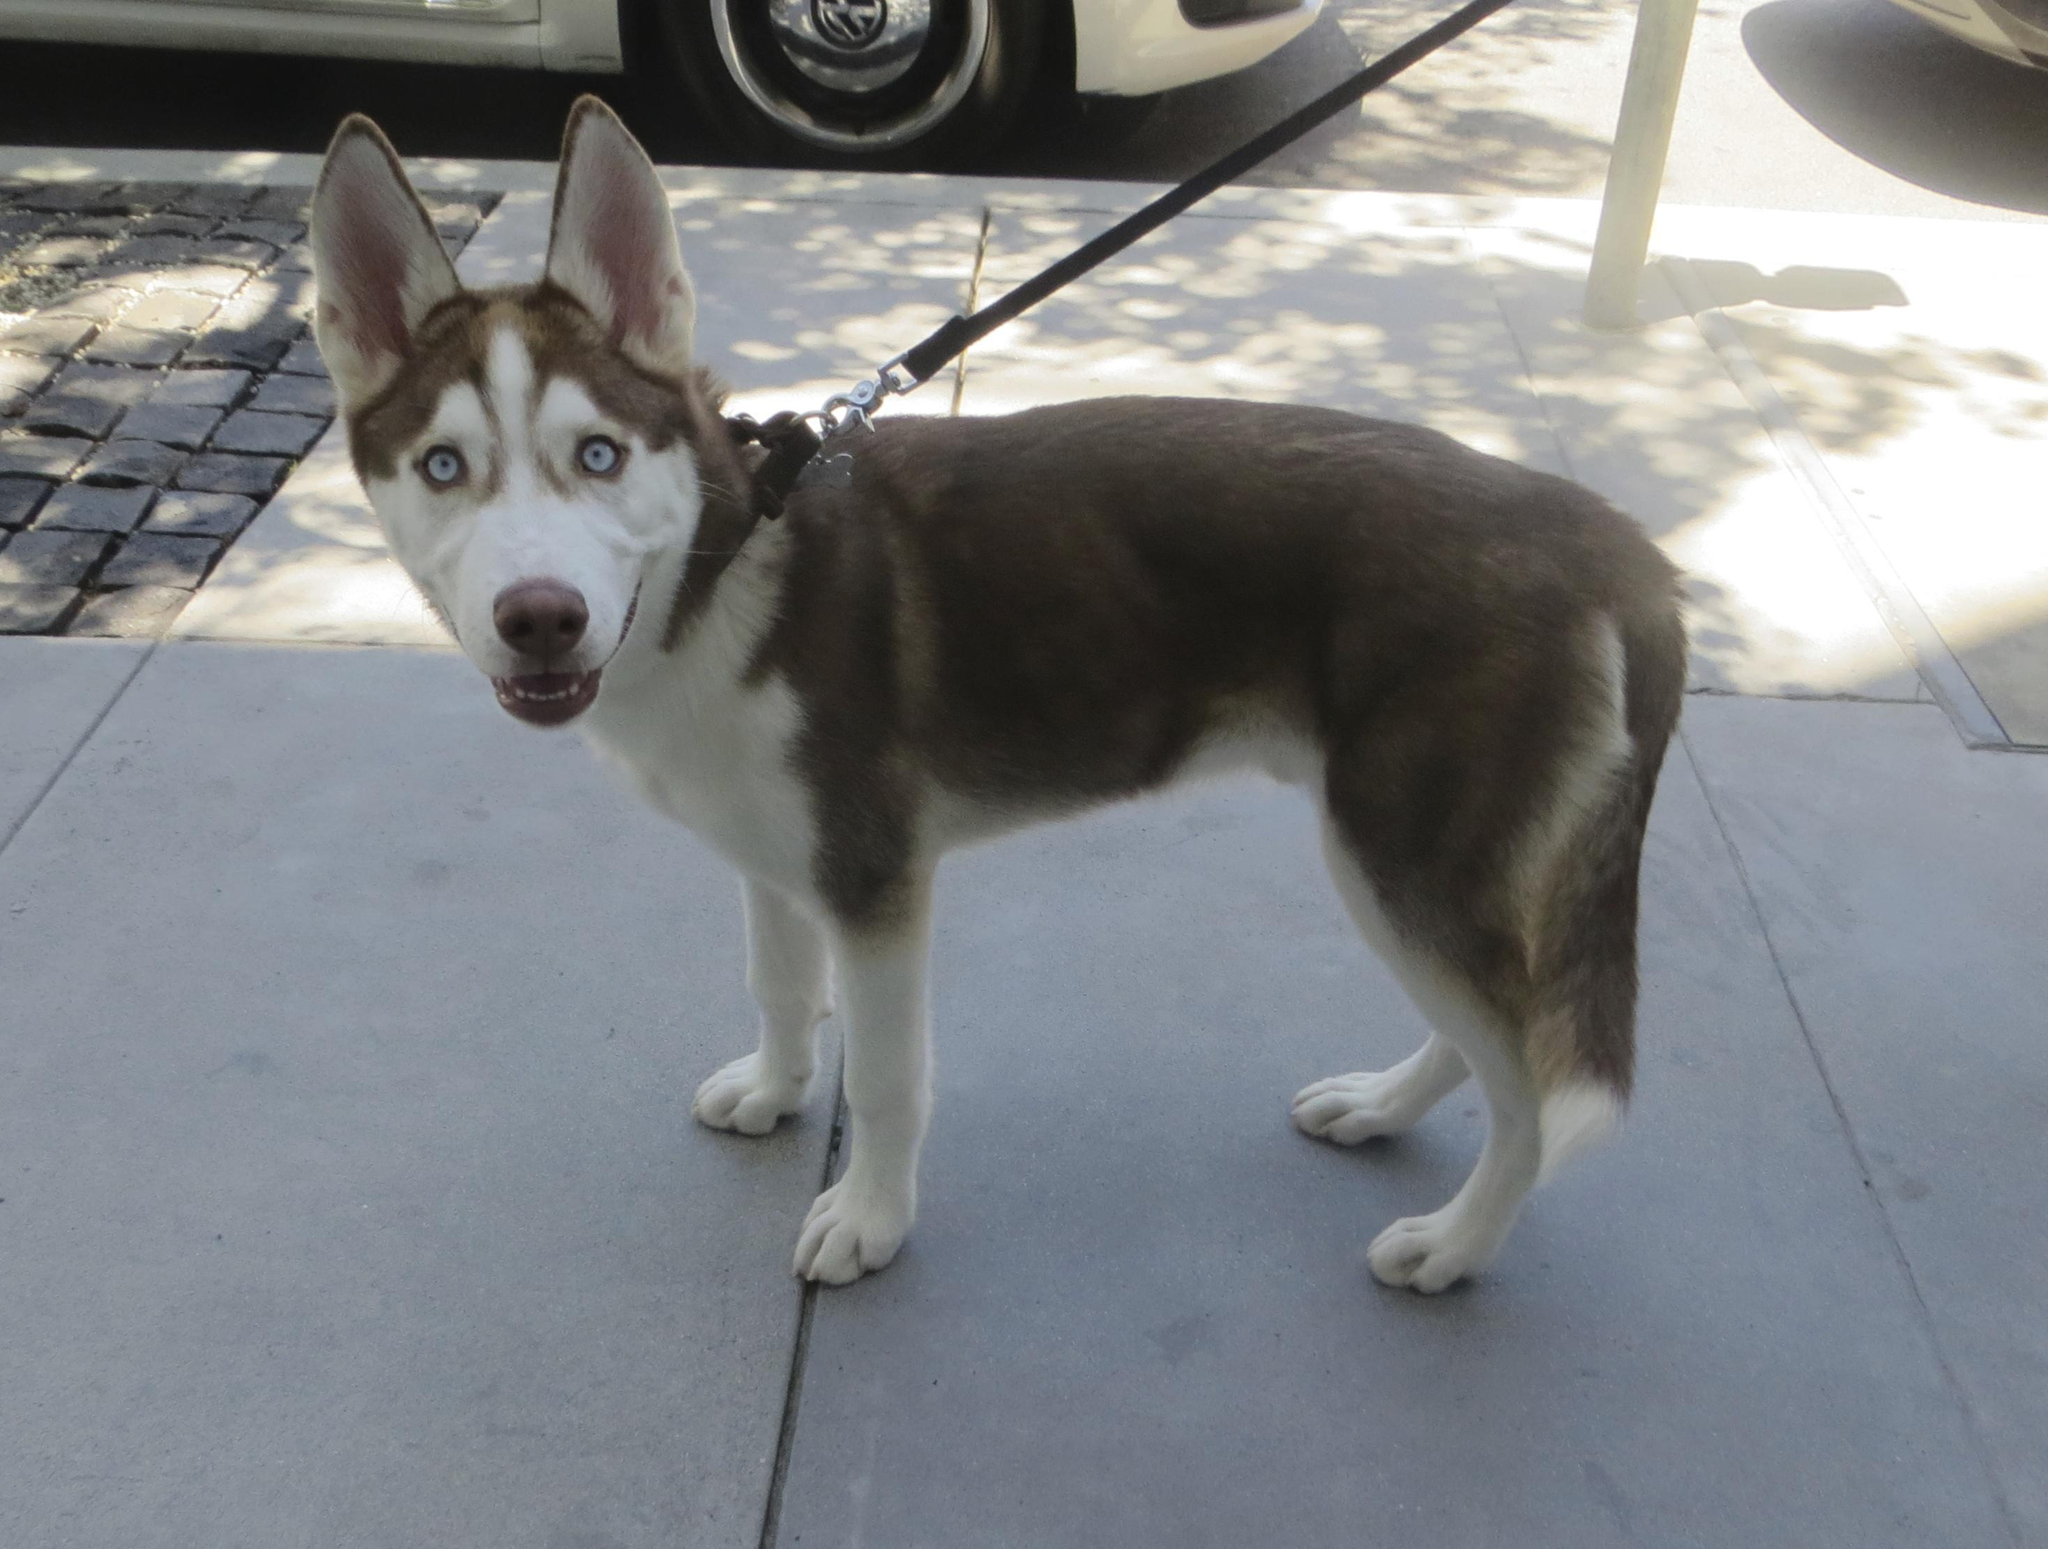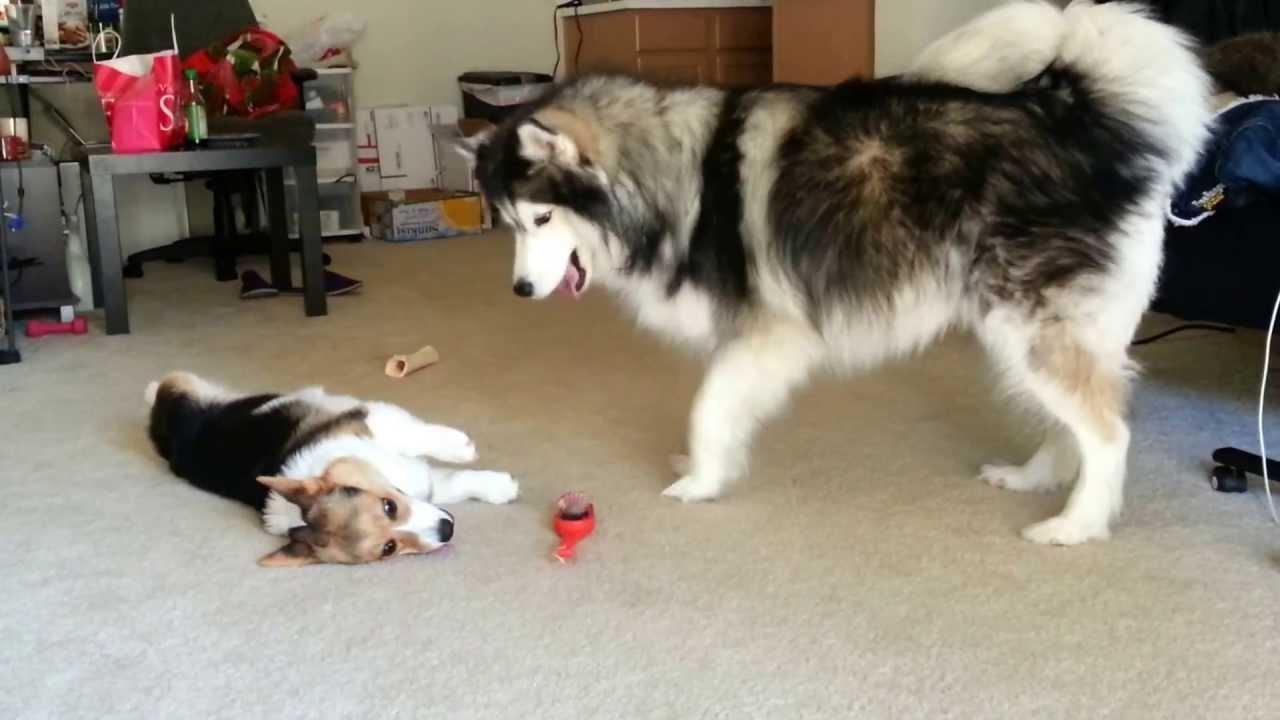The first image is the image on the left, the second image is the image on the right. For the images displayed, is the sentence "Each image contains two husky dogs positioned close together, and one image features dogs standing on snow-covered ground." factually correct? Answer yes or no. No. The first image is the image on the left, the second image is the image on the right. For the images shown, is this caption "The left image contains exactly two dogs." true? Answer yes or no. No. 